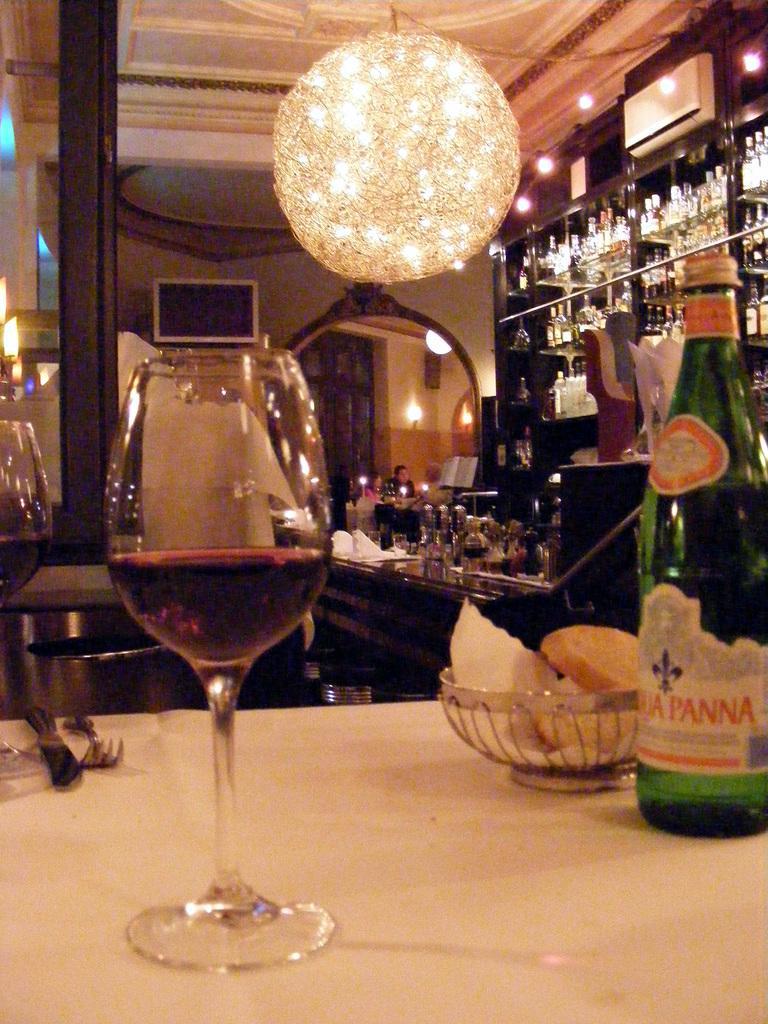Please provide a concise description of this image. In this image I can see the wine bottles, glasses and many objects are on the table. To the right I can see the wine rack. In the background there are two people. I can also see the lights and also chandelier light in the top. 